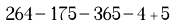Convert formula to latex. <formula><loc_0><loc_0><loc_500><loc_500>2 6 4 - 1 7 5 - 3 6 5 - 4 + 5</formula> 